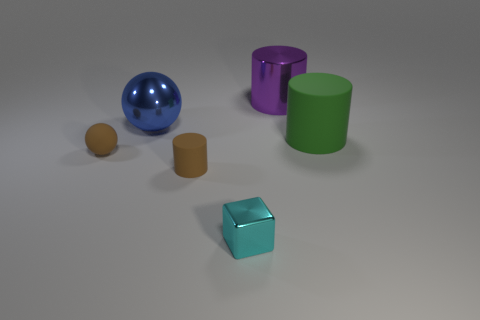What is the brown cylinder made of?
Your response must be concise. Rubber. There is a big thing that is made of the same material as the blue ball; what color is it?
Give a very brief answer. Purple. Is the large blue ball made of the same material as the cylinder that is on the left side of the small cyan block?
Provide a short and direct response. No. What number of small cubes are made of the same material as the tiny cyan object?
Provide a short and direct response. 0. There is a tiny brown object left of the blue metal thing; what is its shape?
Keep it short and to the point. Sphere. Is the material of the small sphere in front of the purple cylinder the same as the large thing to the left of the small metal cube?
Give a very brief answer. No. Is there a brown thing that has the same shape as the small cyan metallic thing?
Your response must be concise. No. How many things are either tiny brown rubber things on the left side of the large blue metallic thing or purple shiny objects?
Offer a very short reply. 2. Is the number of small brown things to the left of the tiny cyan metallic thing greater than the number of big purple cylinders right of the purple object?
Make the answer very short. Yes. How many metal objects are purple cylinders or big things?
Ensure brevity in your answer.  2. 